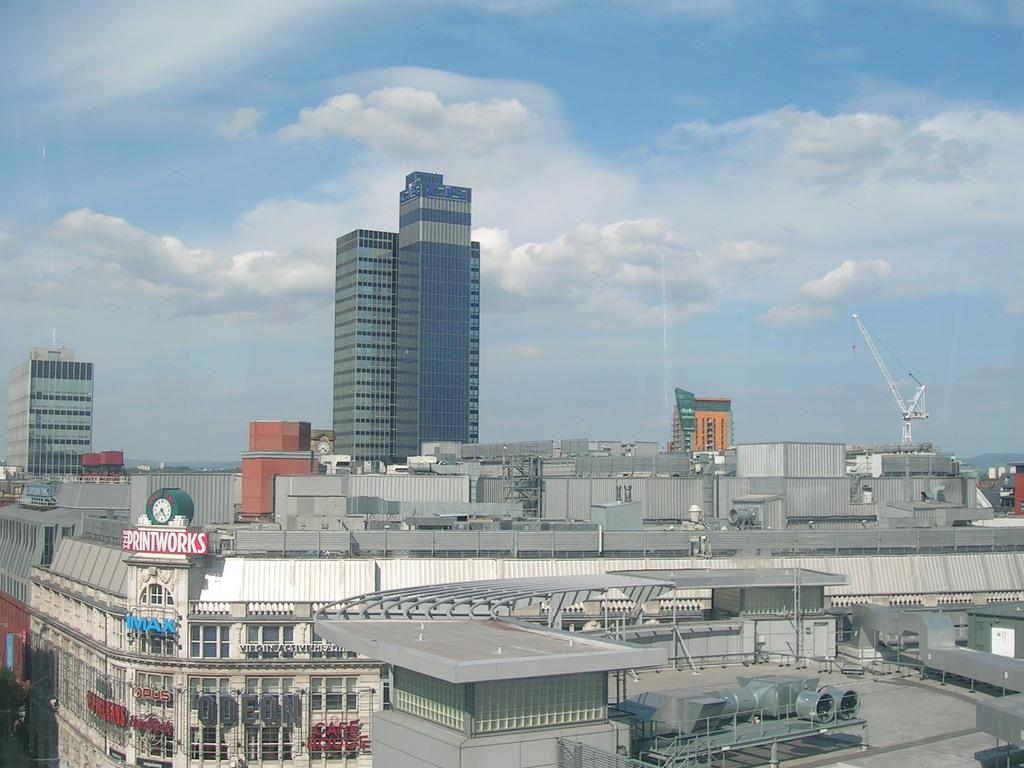What type of structures can be seen in the image? There are buildings in the image. What is the board associated with the buildings used for? The purpose of the board associated with the buildings is not specified in the facts. What type of buildings can be seen in the background? There are tower buildings with glass in the background. What is visible in the background of the image? The sky is visible in the background, and clouds are present in the sky. How many pots can be seen floating in the sea in the image? There is no sea or pot present in the image. How many chairs are placed around the buildings in the image? The number of chairs is not mentioned in the facts, and no chairs are visible in the image. 